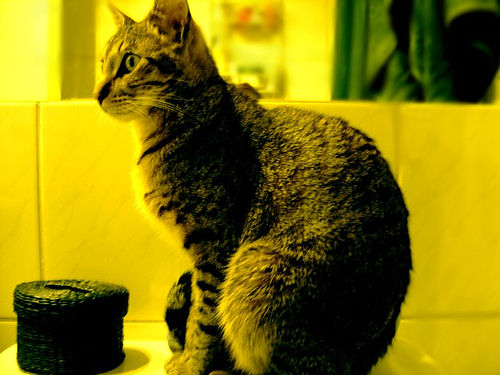<image>What is the name of this cat? I don't know the name of this cat. It could be 'socks', 'tiger', 'tabby', 'pewter', 'boris', 'johnson', 'sparky', or 'kitty'. What is directly in front of the cat? It is unclear what is directly in front of the cat. It could be a basket, a container, a box or a jar. What is directly in front of the cat? I don't know what is directly in front of the cat. It can be a basket, container, box, wicker basket, storage basket, jar or a small container. What is the name of this cat? I don't know the name of this cat. It can be either 'socks', 'tiger', 'tabby', 'pewter', 'boris', 'johnson', 'sparky' or 'kitty'. 